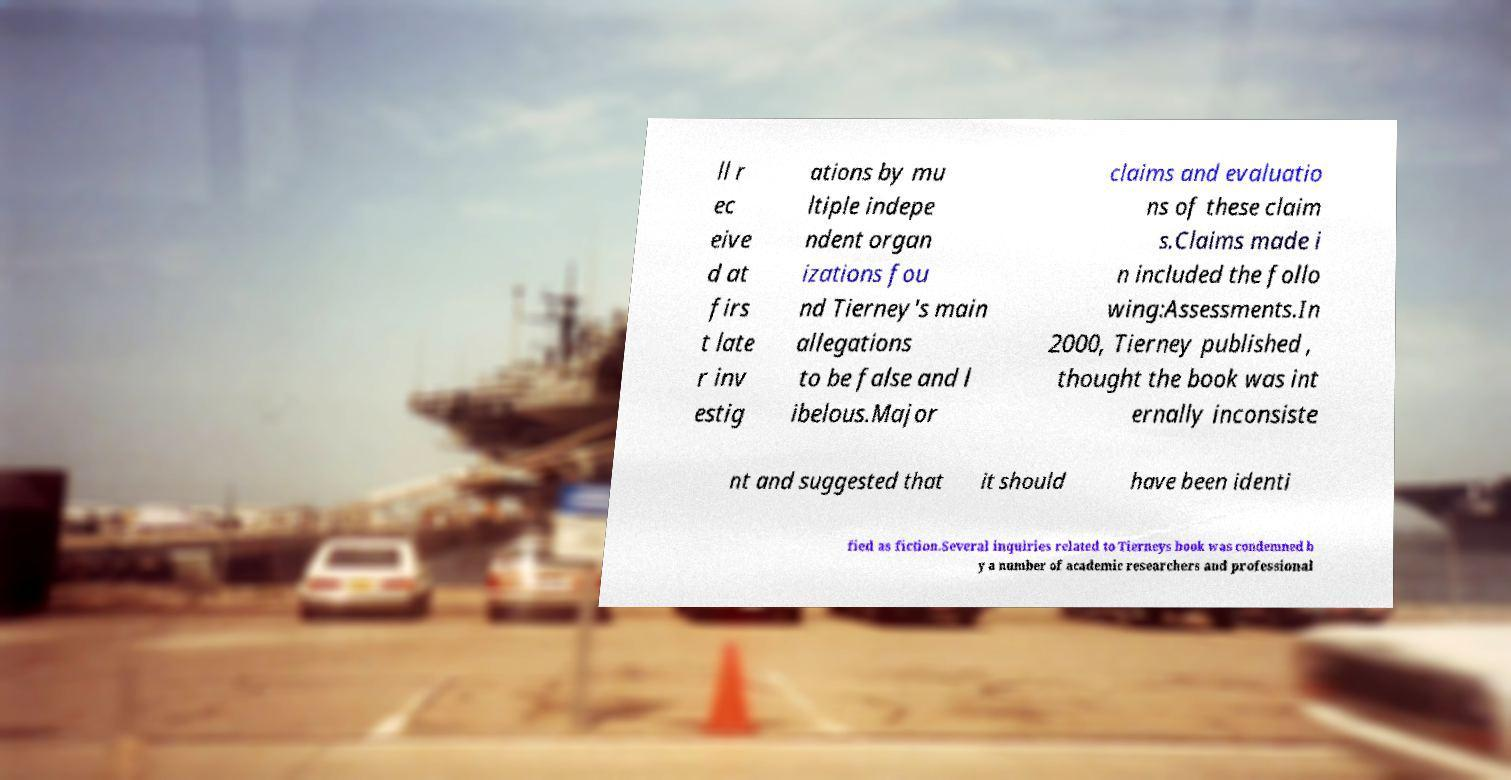Could you assist in decoding the text presented in this image and type it out clearly? ll r ec eive d at firs t late r inv estig ations by mu ltiple indepe ndent organ izations fou nd Tierney's main allegations to be false and l ibelous.Major claims and evaluatio ns of these claim s.Claims made i n included the follo wing:Assessments.In 2000, Tierney published , thought the book was int ernally inconsiste nt and suggested that it should have been identi fied as fiction.Several inquiries related to Tierneys book was condemned b y a number of academic researchers and professional 